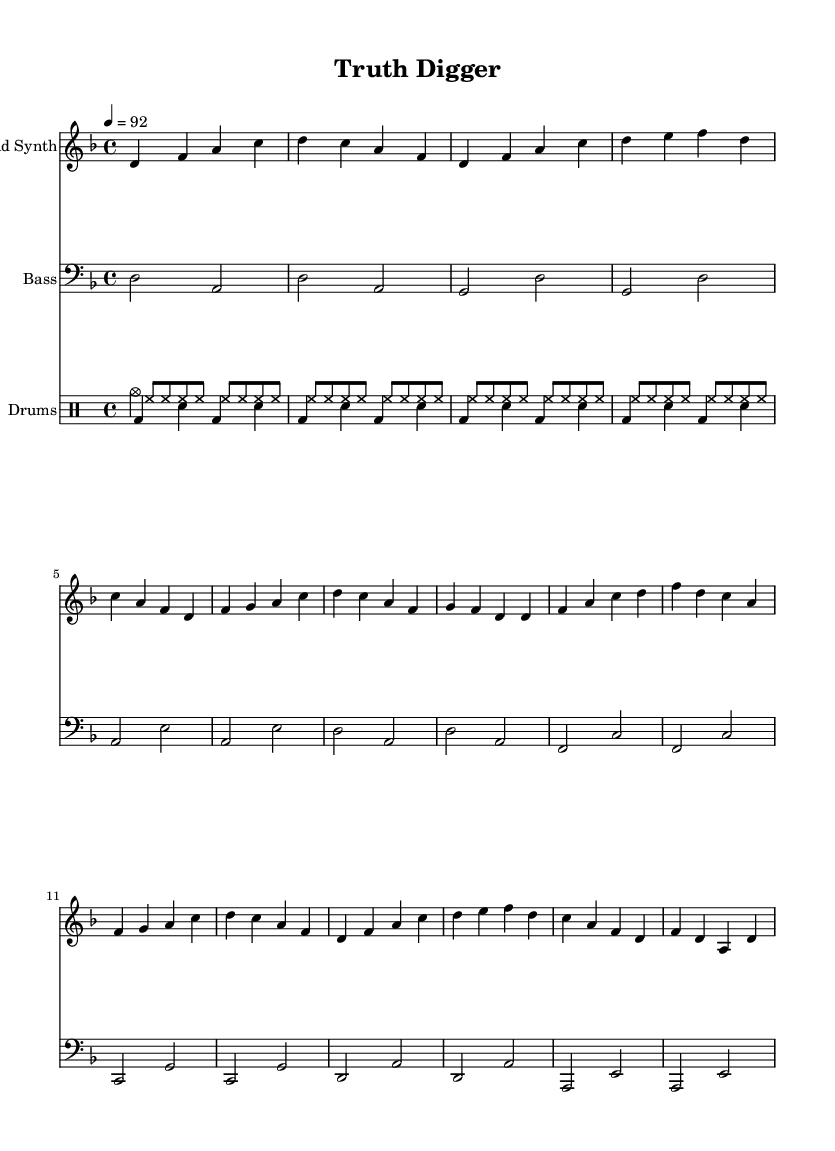What is the key signature of this music? The key signature is D minor, which has one flat (B flat). It's indicated at the beginning of the staff.
Answer: D minor What is the time signature of this music? The time signature is 4/4, which means there are four beats per measure and a quarter note gets one beat. This is shown at the beginning of the sheet music.
Answer: 4/4 What is the tempo of this music? The tempo indication is 4 = 92, meaning there should be 92 beats per minute, with the quarter note receiving the beat. This is found in the tempo marking at the start.
Answer: 92 How many measures are in the verse section? The verse section contains 8 measures, as I can count the groupings of notes and observe the structure of the repeated sections.
Answer: 8 What types of instruments are used in this composition? The music includes lead synth, bass, and drums, which are specified at the beginning of their respective staffs.
Answer: Lead synth, bass, drums In the chorus section, which note appears as the first note? The first note of the chorus is F, which starts the sequence in the chorus part, identified by its placement in the score.
Answer: F How is the rhythm style characterized in this hip hop piece? The rhythm style features a strong emphasis on beats with a mix of kick, snare, and hi-hat patterns in the drum section, typical for hip hop to create a punchy feel.
Answer: Strong beats 